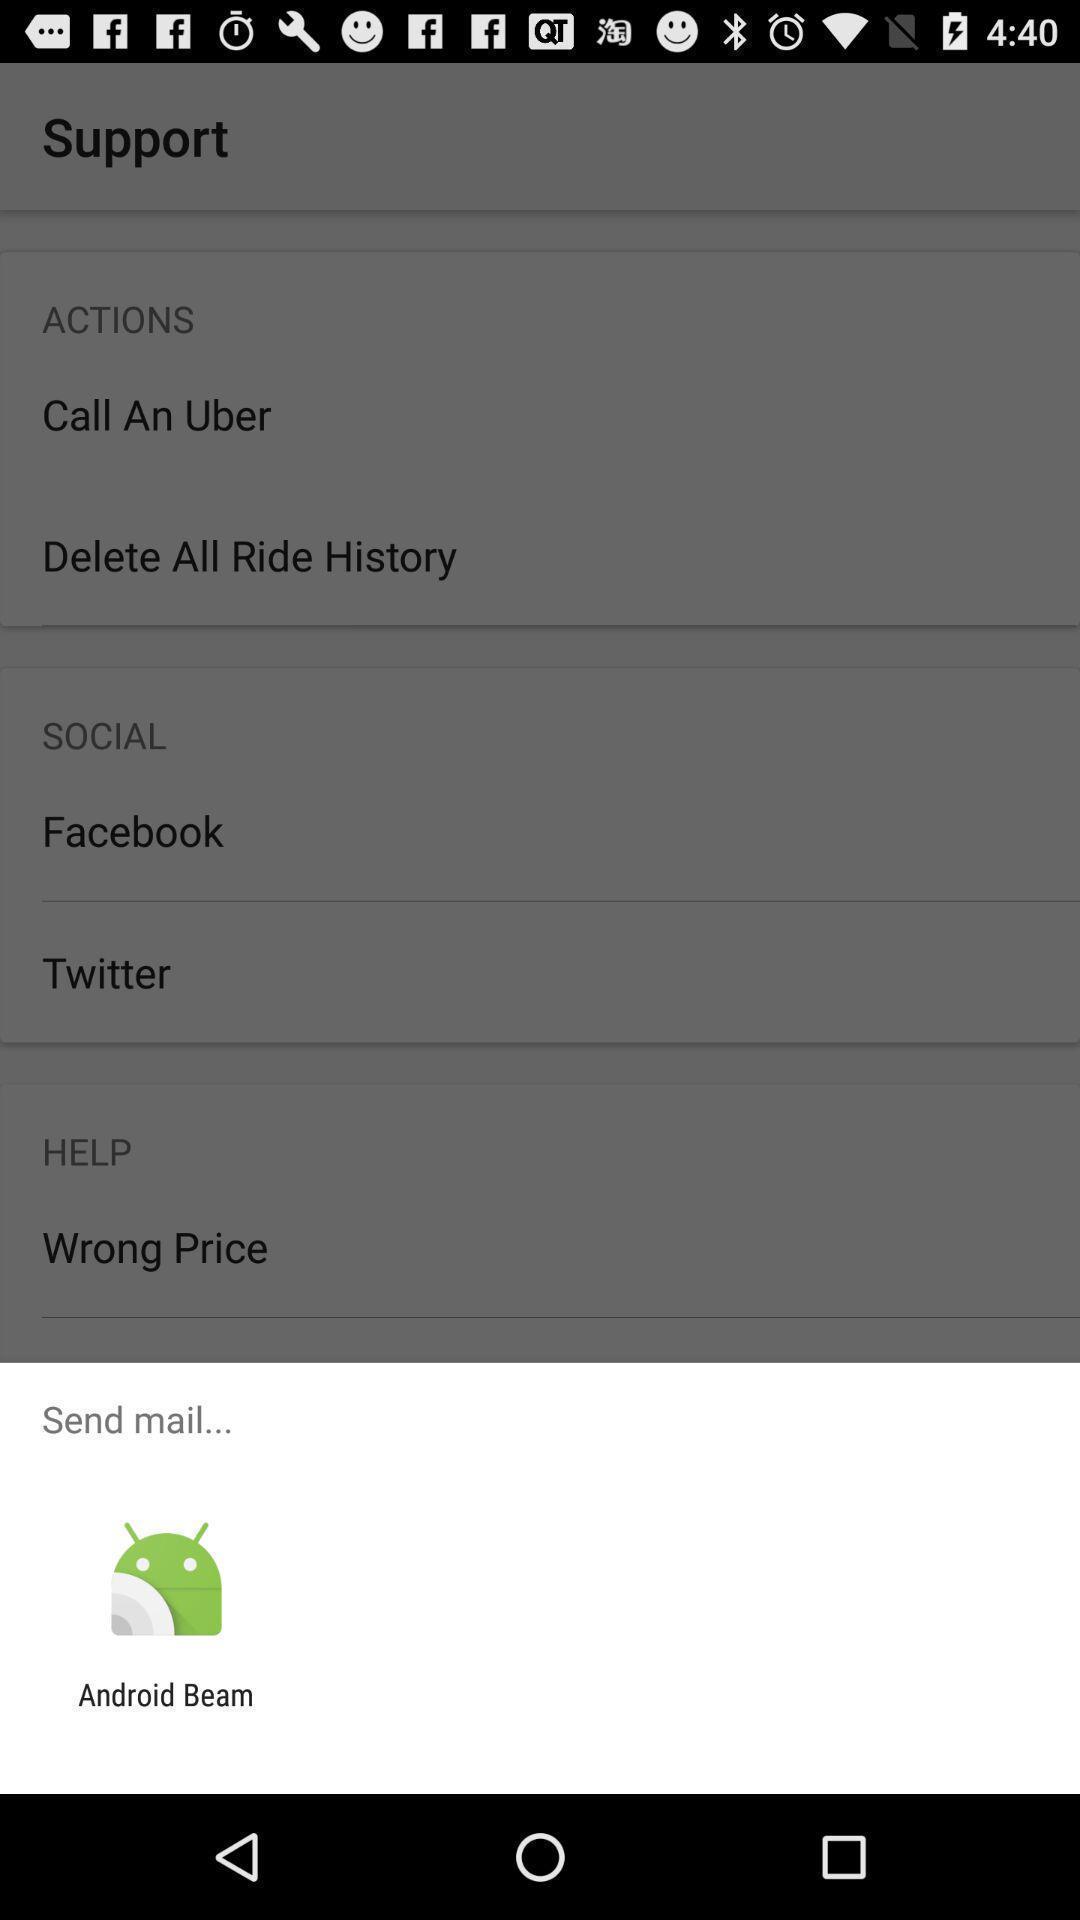Describe the key features of this screenshot. Widget showing a data sharing app. 